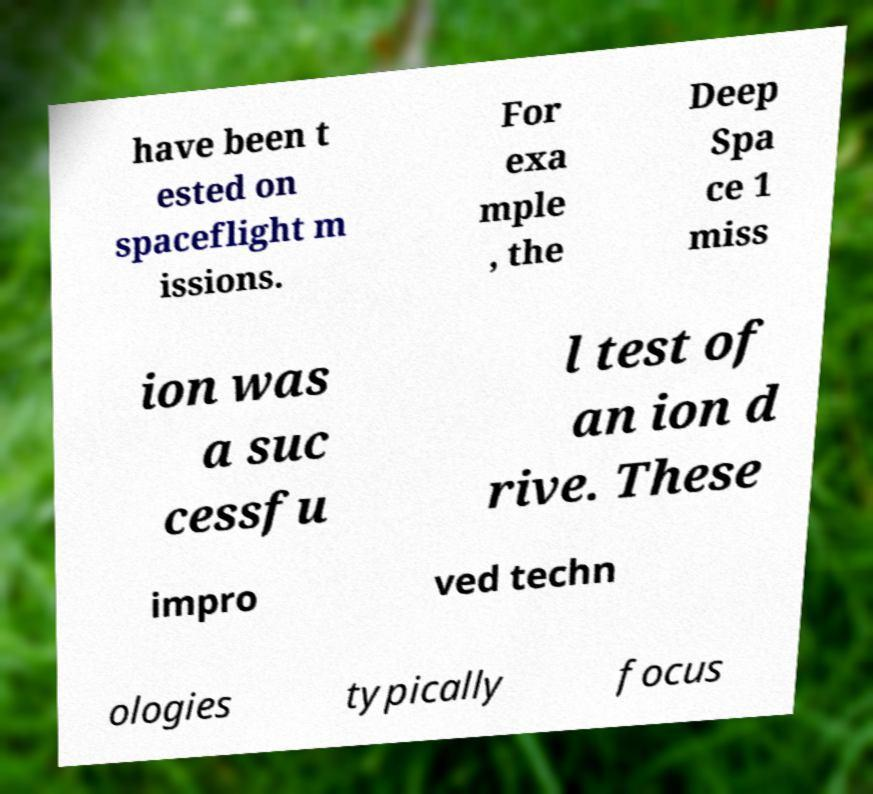For documentation purposes, I need the text within this image transcribed. Could you provide that? have been t ested on spaceflight m issions. For exa mple , the Deep Spa ce 1 miss ion was a suc cessfu l test of an ion d rive. These impro ved techn ologies typically focus 